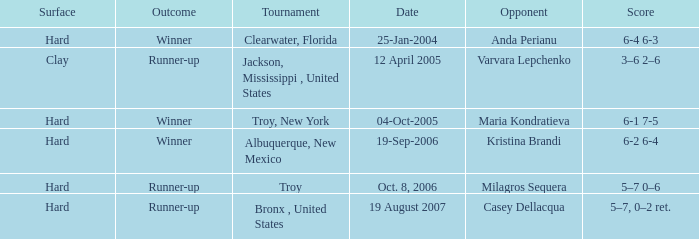What is the final score of the tournament played in Clearwater, Florida? 6-4 6-3. 